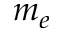Convert formula to latex. <formula><loc_0><loc_0><loc_500><loc_500>m _ { e }</formula> 